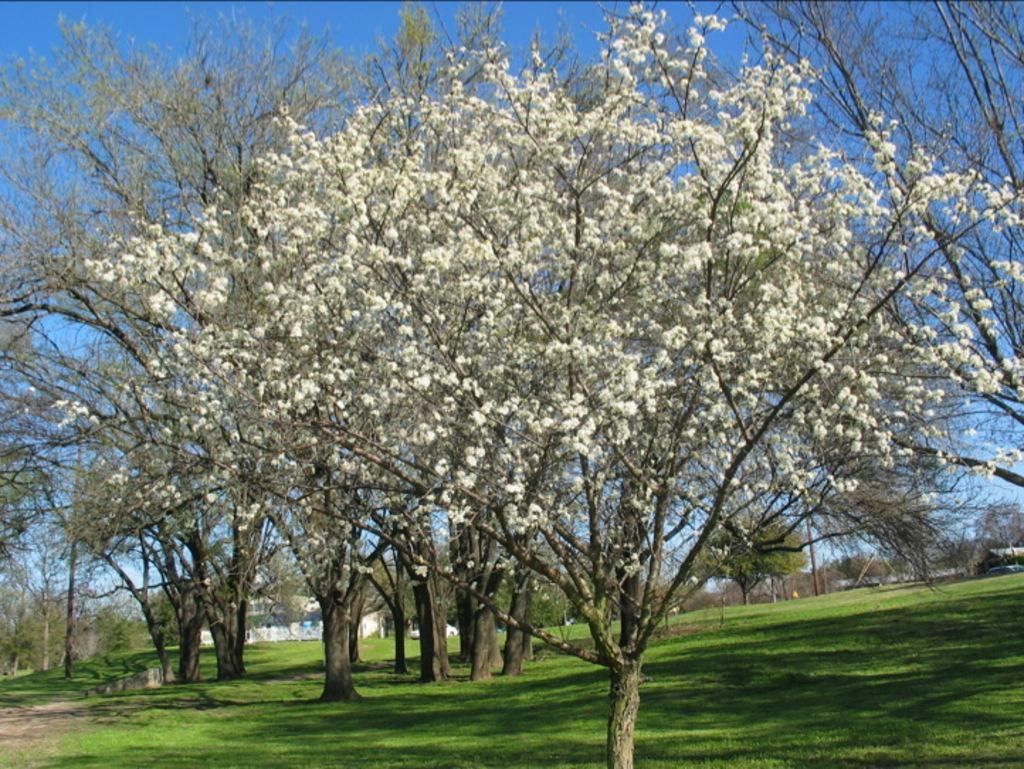What type of vegetation is at the bottom of the image? There is grass at the bottom of the image. What other natural elements can be seen in the image? There are trees and leaves in the image. What is visible at the top of the image? The sky is visible at the top of the image. How many crows are perched on the pump in the image? There is no pump or crow present in the image. What type of attempt is being made in the image? There is no attempt being made in the image; it features grass, trees, leaves, and the sky. 